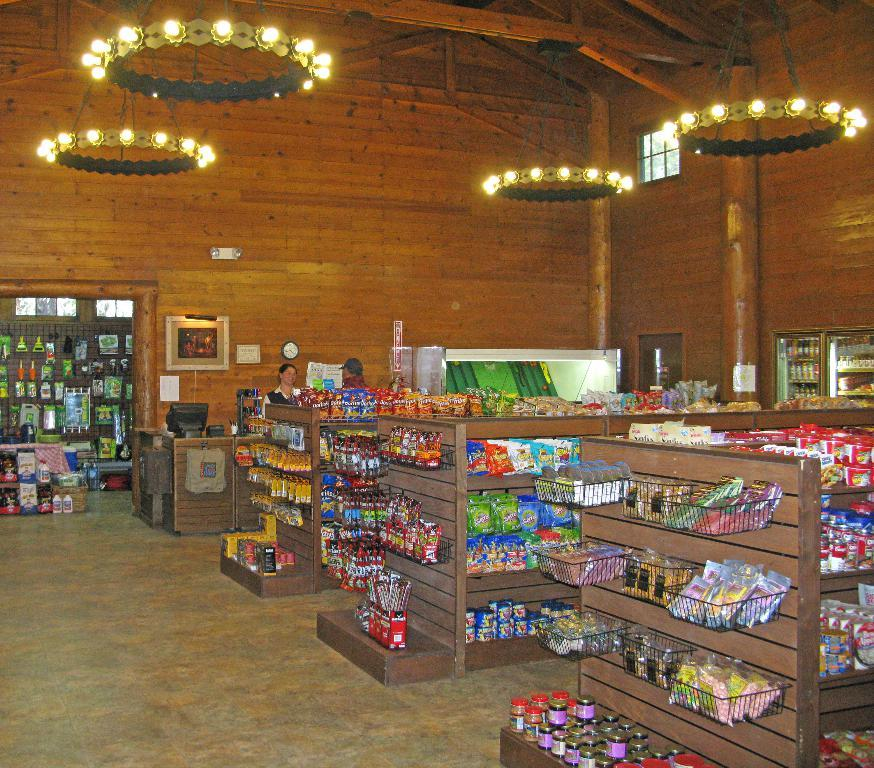What type of establishment is depicted in the image? The image shows the interior of a store. What is the store made of? The store is made of wood. What type of items can be found in the store? Food items are present in the store, as well as other products placed in racks. What type of zinc can be seen in the image? There is no zinc present in the image. How many crackers are visible on the shelves in the image? The image does not specify the presence of crackers, so it cannot be determined how many would be visible on the shelves. 